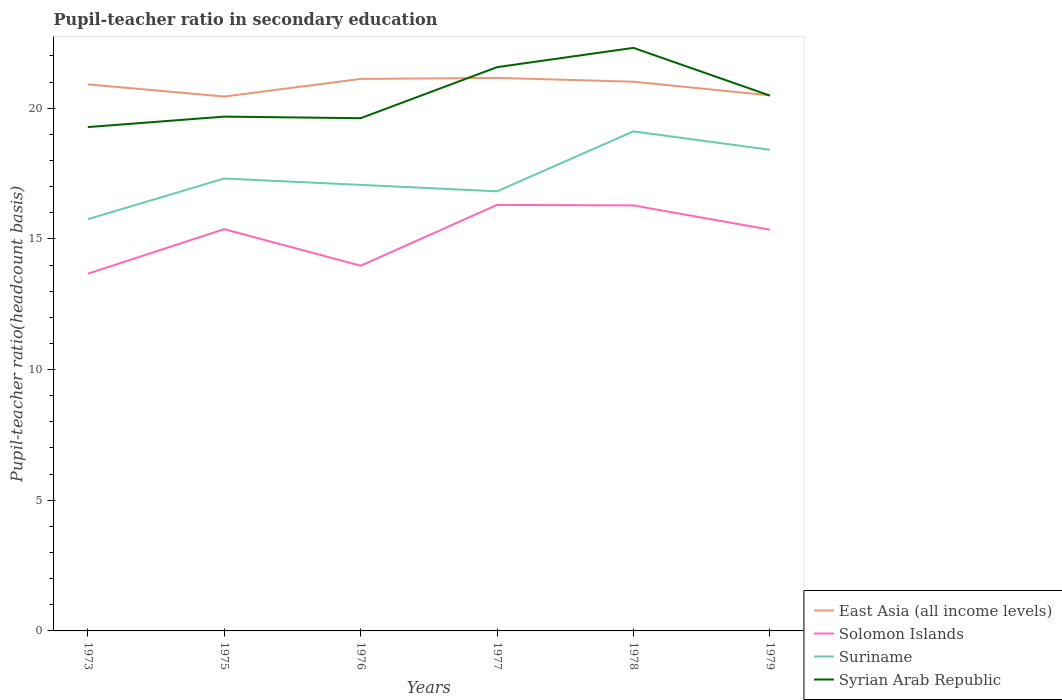Across all years, what is the maximum pupil-teacher ratio in secondary education in Syrian Arab Republic?
Your answer should be compact. 19.28. In which year was the pupil-teacher ratio in secondary education in East Asia (all income levels) maximum?
Keep it short and to the point. 1975. What is the total pupil-teacher ratio in secondary education in Syrian Arab Republic in the graph?
Your response must be concise. -0.34. What is the difference between the highest and the second highest pupil-teacher ratio in secondary education in Suriname?
Your response must be concise. 3.36. What is the difference between the highest and the lowest pupil-teacher ratio in secondary education in East Asia (all income levels)?
Offer a very short reply. 4. How many lines are there?
Your response must be concise. 4. What is the difference between two consecutive major ticks on the Y-axis?
Ensure brevity in your answer.  5. What is the title of the graph?
Give a very brief answer. Pupil-teacher ratio in secondary education. Does "East Asia (developing only)" appear as one of the legend labels in the graph?
Provide a succinct answer. No. What is the label or title of the X-axis?
Provide a short and direct response. Years. What is the label or title of the Y-axis?
Make the answer very short. Pupil-teacher ratio(headcount basis). What is the Pupil-teacher ratio(headcount basis) in East Asia (all income levels) in 1973?
Keep it short and to the point. 20.91. What is the Pupil-teacher ratio(headcount basis) of Solomon Islands in 1973?
Your answer should be compact. 13.67. What is the Pupil-teacher ratio(headcount basis) of Suriname in 1973?
Your answer should be very brief. 15.75. What is the Pupil-teacher ratio(headcount basis) of Syrian Arab Republic in 1973?
Offer a terse response. 19.28. What is the Pupil-teacher ratio(headcount basis) in East Asia (all income levels) in 1975?
Your response must be concise. 20.45. What is the Pupil-teacher ratio(headcount basis) in Solomon Islands in 1975?
Offer a terse response. 15.37. What is the Pupil-teacher ratio(headcount basis) in Suriname in 1975?
Provide a succinct answer. 17.31. What is the Pupil-teacher ratio(headcount basis) in Syrian Arab Republic in 1975?
Offer a terse response. 19.68. What is the Pupil-teacher ratio(headcount basis) in East Asia (all income levels) in 1976?
Provide a succinct answer. 21.12. What is the Pupil-teacher ratio(headcount basis) in Solomon Islands in 1976?
Provide a short and direct response. 13.97. What is the Pupil-teacher ratio(headcount basis) of Suriname in 1976?
Your answer should be very brief. 17.07. What is the Pupil-teacher ratio(headcount basis) of Syrian Arab Republic in 1976?
Give a very brief answer. 19.62. What is the Pupil-teacher ratio(headcount basis) in East Asia (all income levels) in 1977?
Offer a very short reply. 21.16. What is the Pupil-teacher ratio(headcount basis) of Solomon Islands in 1977?
Provide a succinct answer. 16.3. What is the Pupil-teacher ratio(headcount basis) in Suriname in 1977?
Ensure brevity in your answer.  16.82. What is the Pupil-teacher ratio(headcount basis) in Syrian Arab Republic in 1977?
Your answer should be very brief. 21.57. What is the Pupil-teacher ratio(headcount basis) in East Asia (all income levels) in 1978?
Make the answer very short. 21.02. What is the Pupil-teacher ratio(headcount basis) in Solomon Islands in 1978?
Your answer should be very brief. 16.28. What is the Pupil-teacher ratio(headcount basis) of Suriname in 1978?
Your answer should be compact. 19.12. What is the Pupil-teacher ratio(headcount basis) of Syrian Arab Republic in 1978?
Keep it short and to the point. 22.31. What is the Pupil-teacher ratio(headcount basis) of East Asia (all income levels) in 1979?
Your answer should be very brief. 20.49. What is the Pupil-teacher ratio(headcount basis) in Solomon Islands in 1979?
Keep it short and to the point. 15.35. What is the Pupil-teacher ratio(headcount basis) in Suriname in 1979?
Your answer should be compact. 18.41. What is the Pupil-teacher ratio(headcount basis) in Syrian Arab Republic in 1979?
Your response must be concise. 20.49. Across all years, what is the maximum Pupil-teacher ratio(headcount basis) of East Asia (all income levels)?
Your response must be concise. 21.16. Across all years, what is the maximum Pupil-teacher ratio(headcount basis) of Solomon Islands?
Make the answer very short. 16.3. Across all years, what is the maximum Pupil-teacher ratio(headcount basis) of Suriname?
Offer a terse response. 19.12. Across all years, what is the maximum Pupil-teacher ratio(headcount basis) in Syrian Arab Republic?
Your answer should be very brief. 22.31. Across all years, what is the minimum Pupil-teacher ratio(headcount basis) of East Asia (all income levels)?
Offer a very short reply. 20.45. Across all years, what is the minimum Pupil-teacher ratio(headcount basis) in Solomon Islands?
Offer a very short reply. 13.67. Across all years, what is the minimum Pupil-teacher ratio(headcount basis) in Suriname?
Keep it short and to the point. 15.75. Across all years, what is the minimum Pupil-teacher ratio(headcount basis) of Syrian Arab Republic?
Keep it short and to the point. 19.28. What is the total Pupil-teacher ratio(headcount basis) of East Asia (all income levels) in the graph?
Offer a terse response. 125.15. What is the total Pupil-teacher ratio(headcount basis) of Solomon Islands in the graph?
Offer a very short reply. 90.95. What is the total Pupil-teacher ratio(headcount basis) of Suriname in the graph?
Your response must be concise. 104.48. What is the total Pupil-teacher ratio(headcount basis) in Syrian Arab Republic in the graph?
Give a very brief answer. 122.95. What is the difference between the Pupil-teacher ratio(headcount basis) in East Asia (all income levels) in 1973 and that in 1975?
Give a very brief answer. 0.47. What is the difference between the Pupil-teacher ratio(headcount basis) in Solomon Islands in 1973 and that in 1975?
Your answer should be compact. -1.71. What is the difference between the Pupil-teacher ratio(headcount basis) in Suriname in 1973 and that in 1975?
Give a very brief answer. -1.56. What is the difference between the Pupil-teacher ratio(headcount basis) of Syrian Arab Republic in 1973 and that in 1975?
Provide a succinct answer. -0.4. What is the difference between the Pupil-teacher ratio(headcount basis) of East Asia (all income levels) in 1973 and that in 1976?
Your answer should be compact. -0.21. What is the difference between the Pupil-teacher ratio(headcount basis) of Solomon Islands in 1973 and that in 1976?
Offer a terse response. -0.31. What is the difference between the Pupil-teacher ratio(headcount basis) in Suriname in 1973 and that in 1976?
Provide a short and direct response. -1.31. What is the difference between the Pupil-teacher ratio(headcount basis) of Syrian Arab Republic in 1973 and that in 1976?
Give a very brief answer. -0.34. What is the difference between the Pupil-teacher ratio(headcount basis) in East Asia (all income levels) in 1973 and that in 1977?
Offer a very short reply. -0.25. What is the difference between the Pupil-teacher ratio(headcount basis) in Solomon Islands in 1973 and that in 1977?
Make the answer very short. -2.63. What is the difference between the Pupil-teacher ratio(headcount basis) of Suriname in 1973 and that in 1977?
Make the answer very short. -1.07. What is the difference between the Pupil-teacher ratio(headcount basis) of Syrian Arab Republic in 1973 and that in 1977?
Give a very brief answer. -2.29. What is the difference between the Pupil-teacher ratio(headcount basis) of East Asia (all income levels) in 1973 and that in 1978?
Ensure brevity in your answer.  -0.1. What is the difference between the Pupil-teacher ratio(headcount basis) of Solomon Islands in 1973 and that in 1978?
Offer a very short reply. -2.61. What is the difference between the Pupil-teacher ratio(headcount basis) in Suriname in 1973 and that in 1978?
Provide a succinct answer. -3.36. What is the difference between the Pupil-teacher ratio(headcount basis) in Syrian Arab Republic in 1973 and that in 1978?
Provide a short and direct response. -3.03. What is the difference between the Pupil-teacher ratio(headcount basis) of East Asia (all income levels) in 1973 and that in 1979?
Your answer should be very brief. 0.42. What is the difference between the Pupil-teacher ratio(headcount basis) of Solomon Islands in 1973 and that in 1979?
Offer a terse response. -1.68. What is the difference between the Pupil-teacher ratio(headcount basis) in Suriname in 1973 and that in 1979?
Your answer should be compact. -2.66. What is the difference between the Pupil-teacher ratio(headcount basis) in Syrian Arab Republic in 1973 and that in 1979?
Provide a short and direct response. -1.21. What is the difference between the Pupil-teacher ratio(headcount basis) in East Asia (all income levels) in 1975 and that in 1976?
Provide a short and direct response. -0.67. What is the difference between the Pupil-teacher ratio(headcount basis) in Solomon Islands in 1975 and that in 1976?
Offer a very short reply. 1.4. What is the difference between the Pupil-teacher ratio(headcount basis) of Suriname in 1975 and that in 1976?
Offer a very short reply. 0.24. What is the difference between the Pupil-teacher ratio(headcount basis) in Syrian Arab Republic in 1975 and that in 1976?
Provide a short and direct response. 0.06. What is the difference between the Pupil-teacher ratio(headcount basis) in East Asia (all income levels) in 1975 and that in 1977?
Give a very brief answer. -0.71. What is the difference between the Pupil-teacher ratio(headcount basis) in Solomon Islands in 1975 and that in 1977?
Your answer should be compact. -0.93. What is the difference between the Pupil-teacher ratio(headcount basis) of Suriname in 1975 and that in 1977?
Your answer should be very brief. 0.49. What is the difference between the Pupil-teacher ratio(headcount basis) of Syrian Arab Republic in 1975 and that in 1977?
Offer a very short reply. -1.89. What is the difference between the Pupil-teacher ratio(headcount basis) in East Asia (all income levels) in 1975 and that in 1978?
Offer a terse response. -0.57. What is the difference between the Pupil-teacher ratio(headcount basis) in Solomon Islands in 1975 and that in 1978?
Offer a very short reply. -0.91. What is the difference between the Pupil-teacher ratio(headcount basis) of Suriname in 1975 and that in 1978?
Provide a short and direct response. -1.8. What is the difference between the Pupil-teacher ratio(headcount basis) of Syrian Arab Republic in 1975 and that in 1978?
Your response must be concise. -2.63. What is the difference between the Pupil-teacher ratio(headcount basis) in East Asia (all income levels) in 1975 and that in 1979?
Keep it short and to the point. -0.04. What is the difference between the Pupil-teacher ratio(headcount basis) of Solomon Islands in 1975 and that in 1979?
Give a very brief answer. 0.02. What is the difference between the Pupil-teacher ratio(headcount basis) in Suriname in 1975 and that in 1979?
Ensure brevity in your answer.  -1.1. What is the difference between the Pupil-teacher ratio(headcount basis) of Syrian Arab Republic in 1975 and that in 1979?
Your response must be concise. -0.81. What is the difference between the Pupil-teacher ratio(headcount basis) of East Asia (all income levels) in 1976 and that in 1977?
Your response must be concise. -0.04. What is the difference between the Pupil-teacher ratio(headcount basis) in Solomon Islands in 1976 and that in 1977?
Keep it short and to the point. -2.33. What is the difference between the Pupil-teacher ratio(headcount basis) of Suriname in 1976 and that in 1977?
Ensure brevity in your answer.  0.25. What is the difference between the Pupil-teacher ratio(headcount basis) in Syrian Arab Republic in 1976 and that in 1977?
Your answer should be compact. -1.95. What is the difference between the Pupil-teacher ratio(headcount basis) of East Asia (all income levels) in 1976 and that in 1978?
Keep it short and to the point. 0.11. What is the difference between the Pupil-teacher ratio(headcount basis) of Solomon Islands in 1976 and that in 1978?
Provide a short and direct response. -2.31. What is the difference between the Pupil-teacher ratio(headcount basis) of Suriname in 1976 and that in 1978?
Ensure brevity in your answer.  -2.05. What is the difference between the Pupil-teacher ratio(headcount basis) of Syrian Arab Republic in 1976 and that in 1978?
Give a very brief answer. -2.69. What is the difference between the Pupil-teacher ratio(headcount basis) in East Asia (all income levels) in 1976 and that in 1979?
Your response must be concise. 0.63. What is the difference between the Pupil-teacher ratio(headcount basis) of Solomon Islands in 1976 and that in 1979?
Keep it short and to the point. -1.38. What is the difference between the Pupil-teacher ratio(headcount basis) in Suriname in 1976 and that in 1979?
Keep it short and to the point. -1.34. What is the difference between the Pupil-teacher ratio(headcount basis) of Syrian Arab Republic in 1976 and that in 1979?
Ensure brevity in your answer.  -0.87. What is the difference between the Pupil-teacher ratio(headcount basis) in East Asia (all income levels) in 1977 and that in 1978?
Offer a terse response. 0.15. What is the difference between the Pupil-teacher ratio(headcount basis) in Solomon Islands in 1977 and that in 1978?
Your response must be concise. 0.02. What is the difference between the Pupil-teacher ratio(headcount basis) of Suriname in 1977 and that in 1978?
Provide a short and direct response. -2.29. What is the difference between the Pupil-teacher ratio(headcount basis) of Syrian Arab Republic in 1977 and that in 1978?
Offer a very short reply. -0.74. What is the difference between the Pupil-teacher ratio(headcount basis) of East Asia (all income levels) in 1977 and that in 1979?
Your answer should be very brief. 0.67. What is the difference between the Pupil-teacher ratio(headcount basis) in Solomon Islands in 1977 and that in 1979?
Give a very brief answer. 0.95. What is the difference between the Pupil-teacher ratio(headcount basis) of Suriname in 1977 and that in 1979?
Keep it short and to the point. -1.59. What is the difference between the Pupil-teacher ratio(headcount basis) of Syrian Arab Republic in 1977 and that in 1979?
Make the answer very short. 1.09. What is the difference between the Pupil-teacher ratio(headcount basis) of East Asia (all income levels) in 1978 and that in 1979?
Keep it short and to the point. 0.52. What is the difference between the Pupil-teacher ratio(headcount basis) of Solomon Islands in 1978 and that in 1979?
Make the answer very short. 0.93. What is the difference between the Pupil-teacher ratio(headcount basis) in Suriname in 1978 and that in 1979?
Your answer should be compact. 0.71. What is the difference between the Pupil-teacher ratio(headcount basis) in Syrian Arab Republic in 1978 and that in 1979?
Ensure brevity in your answer.  1.82. What is the difference between the Pupil-teacher ratio(headcount basis) of East Asia (all income levels) in 1973 and the Pupil-teacher ratio(headcount basis) of Solomon Islands in 1975?
Give a very brief answer. 5.54. What is the difference between the Pupil-teacher ratio(headcount basis) in East Asia (all income levels) in 1973 and the Pupil-teacher ratio(headcount basis) in Suriname in 1975?
Offer a very short reply. 3.6. What is the difference between the Pupil-teacher ratio(headcount basis) of East Asia (all income levels) in 1973 and the Pupil-teacher ratio(headcount basis) of Syrian Arab Republic in 1975?
Your answer should be very brief. 1.23. What is the difference between the Pupil-teacher ratio(headcount basis) of Solomon Islands in 1973 and the Pupil-teacher ratio(headcount basis) of Suriname in 1975?
Your answer should be very brief. -3.64. What is the difference between the Pupil-teacher ratio(headcount basis) in Solomon Islands in 1973 and the Pupil-teacher ratio(headcount basis) in Syrian Arab Republic in 1975?
Offer a terse response. -6.01. What is the difference between the Pupil-teacher ratio(headcount basis) of Suriname in 1973 and the Pupil-teacher ratio(headcount basis) of Syrian Arab Republic in 1975?
Offer a terse response. -3.93. What is the difference between the Pupil-teacher ratio(headcount basis) in East Asia (all income levels) in 1973 and the Pupil-teacher ratio(headcount basis) in Solomon Islands in 1976?
Offer a terse response. 6.94. What is the difference between the Pupil-teacher ratio(headcount basis) of East Asia (all income levels) in 1973 and the Pupil-teacher ratio(headcount basis) of Suriname in 1976?
Provide a short and direct response. 3.85. What is the difference between the Pupil-teacher ratio(headcount basis) in East Asia (all income levels) in 1973 and the Pupil-teacher ratio(headcount basis) in Syrian Arab Republic in 1976?
Offer a very short reply. 1.3. What is the difference between the Pupil-teacher ratio(headcount basis) of Solomon Islands in 1973 and the Pupil-teacher ratio(headcount basis) of Suriname in 1976?
Give a very brief answer. -3.4. What is the difference between the Pupil-teacher ratio(headcount basis) of Solomon Islands in 1973 and the Pupil-teacher ratio(headcount basis) of Syrian Arab Republic in 1976?
Your answer should be compact. -5.95. What is the difference between the Pupil-teacher ratio(headcount basis) of Suriname in 1973 and the Pupil-teacher ratio(headcount basis) of Syrian Arab Republic in 1976?
Ensure brevity in your answer.  -3.86. What is the difference between the Pupil-teacher ratio(headcount basis) of East Asia (all income levels) in 1973 and the Pupil-teacher ratio(headcount basis) of Solomon Islands in 1977?
Ensure brevity in your answer.  4.61. What is the difference between the Pupil-teacher ratio(headcount basis) in East Asia (all income levels) in 1973 and the Pupil-teacher ratio(headcount basis) in Suriname in 1977?
Your response must be concise. 4.09. What is the difference between the Pupil-teacher ratio(headcount basis) of East Asia (all income levels) in 1973 and the Pupil-teacher ratio(headcount basis) of Syrian Arab Republic in 1977?
Provide a succinct answer. -0.66. What is the difference between the Pupil-teacher ratio(headcount basis) of Solomon Islands in 1973 and the Pupil-teacher ratio(headcount basis) of Suriname in 1977?
Your answer should be very brief. -3.15. What is the difference between the Pupil-teacher ratio(headcount basis) in Solomon Islands in 1973 and the Pupil-teacher ratio(headcount basis) in Syrian Arab Republic in 1977?
Your response must be concise. -7.9. What is the difference between the Pupil-teacher ratio(headcount basis) in Suriname in 1973 and the Pupil-teacher ratio(headcount basis) in Syrian Arab Republic in 1977?
Keep it short and to the point. -5.82. What is the difference between the Pupil-teacher ratio(headcount basis) in East Asia (all income levels) in 1973 and the Pupil-teacher ratio(headcount basis) in Solomon Islands in 1978?
Your response must be concise. 4.63. What is the difference between the Pupil-teacher ratio(headcount basis) of East Asia (all income levels) in 1973 and the Pupil-teacher ratio(headcount basis) of Suriname in 1978?
Ensure brevity in your answer.  1.8. What is the difference between the Pupil-teacher ratio(headcount basis) of East Asia (all income levels) in 1973 and the Pupil-teacher ratio(headcount basis) of Syrian Arab Republic in 1978?
Keep it short and to the point. -1.4. What is the difference between the Pupil-teacher ratio(headcount basis) of Solomon Islands in 1973 and the Pupil-teacher ratio(headcount basis) of Suriname in 1978?
Your answer should be compact. -5.45. What is the difference between the Pupil-teacher ratio(headcount basis) in Solomon Islands in 1973 and the Pupil-teacher ratio(headcount basis) in Syrian Arab Republic in 1978?
Offer a terse response. -8.64. What is the difference between the Pupil-teacher ratio(headcount basis) in Suriname in 1973 and the Pupil-teacher ratio(headcount basis) in Syrian Arab Republic in 1978?
Offer a terse response. -6.56. What is the difference between the Pupil-teacher ratio(headcount basis) in East Asia (all income levels) in 1973 and the Pupil-teacher ratio(headcount basis) in Solomon Islands in 1979?
Provide a short and direct response. 5.56. What is the difference between the Pupil-teacher ratio(headcount basis) in East Asia (all income levels) in 1973 and the Pupil-teacher ratio(headcount basis) in Suriname in 1979?
Your response must be concise. 2.5. What is the difference between the Pupil-teacher ratio(headcount basis) in East Asia (all income levels) in 1973 and the Pupil-teacher ratio(headcount basis) in Syrian Arab Republic in 1979?
Provide a short and direct response. 0.43. What is the difference between the Pupil-teacher ratio(headcount basis) of Solomon Islands in 1973 and the Pupil-teacher ratio(headcount basis) of Suriname in 1979?
Your response must be concise. -4.74. What is the difference between the Pupil-teacher ratio(headcount basis) in Solomon Islands in 1973 and the Pupil-teacher ratio(headcount basis) in Syrian Arab Republic in 1979?
Offer a terse response. -6.82. What is the difference between the Pupil-teacher ratio(headcount basis) of Suriname in 1973 and the Pupil-teacher ratio(headcount basis) of Syrian Arab Republic in 1979?
Give a very brief answer. -4.73. What is the difference between the Pupil-teacher ratio(headcount basis) in East Asia (all income levels) in 1975 and the Pupil-teacher ratio(headcount basis) in Solomon Islands in 1976?
Keep it short and to the point. 6.47. What is the difference between the Pupil-teacher ratio(headcount basis) in East Asia (all income levels) in 1975 and the Pupil-teacher ratio(headcount basis) in Suriname in 1976?
Give a very brief answer. 3.38. What is the difference between the Pupil-teacher ratio(headcount basis) of East Asia (all income levels) in 1975 and the Pupil-teacher ratio(headcount basis) of Syrian Arab Republic in 1976?
Your response must be concise. 0.83. What is the difference between the Pupil-teacher ratio(headcount basis) in Solomon Islands in 1975 and the Pupil-teacher ratio(headcount basis) in Suriname in 1976?
Provide a succinct answer. -1.69. What is the difference between the Pupil-teacher ratio(headcount basis) of Solomon Islands in 1975 and the Pupil-teacher ratio(headcount basis) of Syrian Arab Republic in 1976?
Your answer should be very brief. -4.24. What is the difference between the Pupil-teacher ratio(headcount basis) in Suriname in 1975 and the Pupil-teacher ratio(headcount basis) in Syrian Arab Republic in 1976?
Offer a very short reply. -2.31. What is the difference between the Pupil-teacher ratio(headcount basis) in East Asia (all income levels) in 1975 and the Pupil-teacher ratio(headcount basis) in Solomon Islands in 1977?
Provide a short and direct response. 4.15. What is the difference between the Pupil-teacher ratio(headcount basis) of East Asia (all income levels) in 1975 and the Pupil-teacher ratio(headcount basis) of Suriname in 1977?
Provide a succinct answer. 3.63. What is the difference between the Pupil-teacher ratio(headcount basis) of East Asia (all income levels) in 1975 and the Pupil-teacher ratio(headcount basis) of Syrian Arab Republic in 1977?
Your answer should be compact. -1.12. What is the difference between the Pupil-teacher ratio(headcount basis) in Solomon Islands in 1975 and the Pupil-teacher ratio(headcount basis) in Suriname in 1977?
Give a very brief answer. -1.45. What is the difference between the Pupil-teacher ratio(headcount basis) of Solomon Islands in 1975 and the Pupil-teacher ratio(headcount basis) of Syrian Arab Republic in 1977?
Provide a succinct answer. -6.2. What is the difference between the Pupil-teacher ratio(headcount basis) in Suriname in 1975 and the Pupil-teacher ratio(headcount basis) in Syrian Arab Republic in 1977?
Offer a terse response. -4.26. What is the difference between the Pupil-teacher ratio(headcount basis) in East Asia (all income levels) in 1975 and the Pupil-teacher ratio(headcount basis) in Solomon Islands in 1978?
Give a very brief answer. 4.17. What is the difference between the Pupil-teacher ratio(headcount basis) of East Asia (all income levels) in 1975 and the Pupil-teacher ratio(headcount basis) of Suriname in 1978?
Provide a short and direct response. 1.33. What is the difference between the Pupil-teacher ratio(headcount basis) in East Asia (all income levels) in 1975 and the Pupil-teacher ratio(headcount basis) in Syrian Arab Republic in 1978?
Offer a very short reply. -1.86. What is the difference between the Pupil-teacher ratio(headcount basis) of Solomon Islands in 1975 and the Pupil-teacher ratio(headcount basis) of Suriname in 1978?
Ensure brevity in your answer.  -3.74. What is the difference between the Pupil-teacher ratio(headcount basis) in Solomon Islands in 1975 and the Pupil-teacher ratio(headcount basis) in Syrian Arab Republic in 1978?
Ensure brevity in your answer.  -6.94. What is the difference between the Pupil-teacher ratio(headcount basis) of Suriname in 1975 and the Pupil-teacher ratio(headcount basis) of Syrian Arab Republic in 1978?
Provide a short and direct response. -5. What is the difference between the Pupil-teacher ratio(headcount basis) of East Asia (all income levels) in 1975 and the Pupil-teacher ratio(headcount basis) of Solomon Islands in 1979?
Provide a short and direct response. 5.1. What is the difference between the Pupil-teacher ratio(headcount basis) of East Asia (all income levels) in 1975 and the Pupil-teacher ratio(headcount basis) of Suriname in 1979?
Ensure brevity in your answer.  2.04. What is the difference between the Pupil-teacher ratio(headcount basis) in East Asia (all income levels) in 1975 and the Pupil-teacher ratio(headcount basis) in Syrian Arab Republic in 1979?
Ensure brevity in your answer.  -0.04. What is the difference between the Pupil-teacher ratio(headcount basis) of Solomon Islands in 1975 and the Pupil-teacher ratio(headcount basis) of Suriname in 1979?
Offer a very short reply. -3.04. What is the difference between the Pupil-teacher ratio(headcount basis) of Solomon Islands in 1975 and the Pupil-teacher ratio(headcount basis) of Syrian Arab Republic in 1979?
Your answer should be very brief. -5.11. What is the difference between the Pupil-teacher ratio(headcount basis) in Suriname in 1975 and the Pupil-teacher ratio(headcount basis) in Syrian Arab Republic in 1979?
Your answer should be compact. -3.17. What is the difference between the Pupil-teacher ratio(headcount basis) of East Asia (all income levels) in 1976 and the Pupil-teacher ratio(headcount basis) of Solomon Islands in 1977?
Make the answer very short. 4.82. What is the difference between the Pupil-teacher ratio(headcount basis) in East Asia (all income levels) in 1976 and the Pupil-teacher ratio(headcount basis) in Suriname in 1977?
Give a very brief answer. 4.3. What is the difference between the Pupil-teacher ratio(headcount basis) in East Asia (all income levels) in 1976 and the Pupil-teacher ratio(headcount basis) in Syrian Arab Republic in 1977?
Offer a terse response. -0.45. What is the difference between the Pupil-teacher ratio(headcount basis) of Solomon Islands in 1976 and the Pupil-teacher ratio(headcount basis) of Suriname in 1977?
Give a very brief answer. -2.85. What is the difference between the Pupil-teacher ratio(headcount basis) in Solomon Islands in 1976 and the Pupil-teacher ratio(headcount basis) in Syrian Arab Republic in 1977?
Your answer should be compact. -7.6. What is the difference between the Pupil-teacher ratio(headcount basis) of Suriname in 1976 and the Pupil-teacher ratio(headcount basis) of Syrian Arab Republic in 1977?
Ensure brevity in your answer.  -4.5. What is the difference between the Pupil-teacher ratio(headcount basis) in East Asia (all income levels) in 1976 and the Pupil-teacher ratio(headcount basis) in Solomon Islands in 1978?
Offer a terse response. 4.84. What is the difference between the Pupil-teacher ratio(headcount basis) of East Asia (all income levels) in 1976 and the Pupil-teacher ratio(headcount basis) of Suriname in 1978?
Make the answer very short. 2.01. What is the difference between the Pupil-teacher ratio(headcount basis) of East Asia (all income levels) in 1976 and the Pupil-teacher ratio(headcount basis) of Syrian Arab Republic in 1978?
Your response must be concise. -1.19. What is the difference between the Pupil-teacher ratio(headcount basis) of Solomon Islands in 1976 and the Pupil-teacher ratio(headcount basis) of Suriname in 1978?
Make the answer very short. -5.14. What is the difference between the Pupil-teacher ratio(headcount basis) in Solomon Islands in 1976 and the Pupil-teacher ratio(headcount basis) in Syrian Arab Republic in 1978?
Keep it short and to the point. -8.34. What is the difference between the Pupil-teacher ratio(headcount basis) of Suriname in 1976 and the Pupil-teacher ratio(headcount basis) of Syrian Arab Republic in 1978?
Ensure brevity in your answer.  -5.24. What is the difference between the Pupil-teacher ratio(headcount basis) in East Asia (all income levels) in 1976 and the Pupil-teacher ratio(headcount basis) in Solomon Islands in 1979?
Provide a succinct answer. 5.77. What is the difference between the Pupil-teacher ratio(headcount basis) in East Asia (all income levels) in 1976 and the Pupil-teacher ratio(headcount basis) in Suriname in 1979?
Offer a very short reply. 2.71. What is the difference between the Pupil-teacher ratio(headcount basis) in East Asia (all income levels) in 1976 and the Pupil-teacher ratio(headcount basis) in Syrian Arab Republic in 1979?
Ensure brevity in your answer.  0.64. What is the difference between the Pupil-teacher ratio(headcount basis) in Solomon Islands in 1976 and the Pupil-teacher ratio(headcount basis) in Suriname in 1979?
Your response must be concise. -4.44. What is the difference between the Pupil-teacher ratio(headcount basis) of Solomon Islands in 1976 and the Pupil-teacher ratio(headcount basis) of Syrian Arab Republic in 1979?
Provide a succinct answer. -6.51. What is the difference between the Pupil-teacher ratio(headcount basis) in Suriname in 1976 and the Pupil-teacher ratio(headcount basis) in Syrian Arab Republic in 1979?
Keep it short and to the point. -3.42. What is the difference between the Pupil-teacher ratio(headcount basis) of East Asia (all income levels) in 1977 and the Pupil-teacher ratio(headcount basis) of Solomon Islands in 1978?
Keep it short and to the point. 4.88. What is the difference between the Pupil-teacher ratio(headcount basis) in East Asia (all income levels) in 1977 and the Pupil-teacher ratio(headcount basis) in Suriname in 1978?
Give a very brief answer. 2.05. What is the difference between the Pupil-teacher ratio(headcount basis) in East Asia (all income levels) in 1977 and the Pupil-teacher ratio(headcount basis) in Syrian Arab Republic in 1978?
Your answer should be compact. -1.15. What is the difference between the Pupil-teacher ratio(headcount basis) in Solomon Islands in 1977 and the Pupil-teacher ratio(headcount basis) in Suriname in 1978?
Offer a very short reply. -2.81. What is the difference between the Pupil-teacher ratio(headcount basis) of Solomon Islands in 1977 and the Pupil-teacher ratio(headcount basis) of Syrian Arab Republic in 1978?
Give a very brief answer. -6.01. What is the difference between the Pupil-teacher ratio(headcount basis) in Suriname in 1977 and the Pupil-teacher ratio(headcount basis) in Syrian Arab Republic in 1978?
Ensure brevity in your answer.  -5.49. What is the difference between the Pupil-teacher ratio(headcount basis) of East Asia (all income levels) in 1977 and the Pupil-teacher ratio(headcount basis) of Solomon Islands in 1979?
Make the answer very short. 5.81. What is the difference between the Pupil-teacher ratio(headcount basis) in East Asia (all income levels) in 1977 and the Pupil-teacher ratio(headcount basis) in Suriname in 1979?
Keep it short and to the point. 2.75. What is the difference between the Pupil-teacher ratio(headcount basis) in East Asia (all income levels) in 1977 and the Pupil-teacher ratio(headcount basis) in Syrian Arab Republic in 1979?
Ensure brevity in your answer.  0.68. What is the difference between the Pupil-teacher ratio(headcount basis) of Solomon Islands in 1977 and the Pupil-teacher ratio(headcount basis) of Suriname in 1979?
Ensure brevity in your answer.  -2.11. What is the difference between the Pupil-teacher ratio(headcount basis) in Solomon Islands in 1977 and the Pupil-teacher ratio(headcount basis) in Syrian Arab Republic in 1979?
Ensure brevity in your answer.  -4.18. What is the difference between the Pupil-teacher ratio(headcount basis) of Suriname in 1977 and the Pupil-teacher ratio(headcount basis) of Syrian Arab Republic in 1979?
Offer a terse response. -3.66. What is the difference between the Pupil-teacher ratio(headcount basis) in East Asia (all income levels) in 1978 and the Pupil-teacher ratio(headcount basis) in Solomon Islands in 1979?
Your response must be concise. 5.66. What is the difference between the Pupil-teacher ratio(headcount basis) in East Asia (all income levels) in 1978 and the Pupil-teacher ratio(headcount basis) in Suriname in 1979?
Offer a terse response. 2.61. What is the difference between the Pupil-teacher ratio(headcount basis) in East Asia (all income levels) in 1978 and the Pupil-teacher ratio(headcount basis) in Syrian Arab Republic in 1979?
Keep it short and to the point. 0.53. What is the difference between the Pupil-teacher ratio(headcount basis) of Solomon Islands in 1978 and the Pupil-teacher ratio(headcount basis) of Suriname in 1979?
Ensure brevity in your answer.  -2.13. What is the difference between the Pupil-teacher ratio(headcount basis) of Solomon Islands in 1978 and the Pupil-teacher ratio(headcount basis) of Syrian Arab Republic in 1979?
Ensure brevity in your answer.  -4.2. What is the difference between the Pupil-teacher ratio(headcount basis) in Suriname in 1978 and the Pupil-teacher ratio(headcount basis) in Syrian Arab Republic in 1979?
Your response must be concise. -1.37. What is the average Pupil-teacher ratio(headcount basis) of East Asia (all income levels) per year?
Give a very brief answer. 20.86. What is the average Pupil-teacher ratio(headcount basis) of Solomon Islands per year?
Your answer should be compact. 15.16. What is the average Pupil-teacher ratio(headcount basis) in Suriname per year?
Give a very brief answer. 17.41. What is the average Pupil-teacher ratio(headcount basis) in Syrian Arab Republic per year?
Keep it short and to the point. 20.49. In the year 1973, what is the difference between the Pupil-teacher ratio(headcount basis) in East Asia (all income levels) and Pupil-teacher ratio(headcount basis) in Solomon Islands?
Offer a very short reply. 7.25. In the year 1973, what is the difference between the Pupil-teacher ratio(headcount basis) in East Asia (all income levels) and Pupil-teacher ratio(headcount basis) in Suriname?
Your answer should be compact. 5.16. In the year 1973, what is the difference between the Pupil-teacher ratio(headcount basis) in East Asia (all income levels) and Pupil-teacher ratio(headcount basis) in Syrian Arab Republic?
Ensure brevity in your answer.  1.63. In the year 1973, what is the difference between the Pupil-teacher ratio(headcount basis) in Solomon Islands and Pupil-teacher ratio(headcount basis) in Suriname?
Make the answer very short. -2.09. In the year 1973, what is the difference between the Pupil-teacher ratio(headcount basis) in Solomon Islands and Pupil-teacher ratio(headcount basis) in Syrian Arab Republic?
Provide a succinct answer. -5.61. In the year 1973, what is the difference between the Pupil-teacher ratio(headcount basis) in Suriname and Pupil-teacher ratio(headcount basis) in Syrian Arab Republic?
Your answer should be compact. -3.52. In the year 1975, what is the difference between the Pupil-teacher ratio(headcount basis) of East Asia (all income levels) and Pupil-teacher ratio(headcount basis) of Solomon Islands?
Make the answer very short. 5.07. In the year 1975, what is the difference between the Pupil-teacher ratio(headcount basis) of East Asia (all income levels) and Pupil-teacher ratio(headcount basis) of Suriname?
Your answer should be very brief. 3.14. In the year 1975, what is the difference between the Pupil-teacher ratio(headcount basis) in East Asia (all income levels) and Pupil-teacher ratio(headcount basis) in Syrian Arab Republic?
Give a very brief answer. 0.77. In the year 1975, what is the difference between the Pupil-teacher ratio(headcount basis) in Solomon Islands and Pupil-teacher ratio(headcount basis) in Suriname?
Your answer should be compact. -1.94. In the year 1975, what is the difference between the Pupil-teacher ratio(headcount basis) of Solomon Islands and Pupil-teacher ratio(headcount basis) of Syrian Arab Republic?
Provide a succinct answer. -4.31. In the year 1975, what is the difference between the Pupil-teacher ratio(headcount basis) of Suriname and Pupil-teacher ratio(headcount basis) of Syrian Arab Republic?
Ensure brevity in your answer.  -2.37. In the year 1976, what is the difference between the Pupil-teacher ratio(headcount basis) of East Asia (all income levels) and Pupil-teacher ratio(headcount basis) of Solomon Islands?
Offer a very short reply. 7.15. In the year 1976, what is the difference between the Pupil-teacher ratio(headcount basis) in East Asia (all income levels) and Pupil-teacher ratio(headcount basis) in Suriname?
Ensure brevity in your answer.  4.05. In the year 1976, what is the difference between the Pupil-teacher ratio(headcount basis) in East Asia (all income levels) and Pupil-teacher ratio(headcount basis) in Syrian Arab Republic?
Provide a short and direct response. 1.5. In the year 1976, what is the difference between the Pupil-teacher ratio(headcount basis) in Solomon Islands and Pupil-teacher ratio(headcount basis) in Suriname?
Make the answer very short. -3.09. In the year 1976, what is the difference between the Pupil-teacher ratio(headcount basis) of Solomon Islands and Pupil-teacher ratio(headcount basis) of Syrian Arab Republic?
Give a very brief answer. -5.64. In the year 1976, what is the difference between the Pupil-teacher ratio(headcount basis) of Suriname and Pupil-teacher ratio(headcount basis) of Syrian Arab Republic?
Give a very brief answer. -2.55. In the year 1977, what is the difference between the Pupil-teacher ratio(headcount basis) in East Asia (all income levels) and Pupil-teacher ratio(headcount basis) in Solomon Islands?
Offer a very short reply. 4.86. In the year 1977, what is the difference between the Pupil-teacher ratio(headcount basis) in East Asia (all income levels) and Pupil-teacher ratio(headcount basis) in Suriname?
Make the answer very short. 4.34. In the year 1977, what is the difference between the Pupil-teacher ratio(headcount basis) in East Asia (all income levels) and Pupil-teacher ratio(headcount basis) in Syrian Arab Republic?
Provide a succinct answer. -0.41. In the year 1977, what is the difference between the Pupil-teacher ratio(headcount basis) of Solomon Islands and Pupil-teacher ratio(headcount basis) of Suriname?
Your answer should be very brief. -0.52. In the year 1977, what is the difference between the Pupil-teacher ratio(headcount basis) of Solomon Islands and Pupil-teacher ratio(headcount basis) of Syrian Arab Republic?
Keep it short and to the point. -5.27. In the year 1977, what is the difference between the Pupil-teacher ratio(headcount basis) in Suriname and Pupil-teacher ratio(headcount basis) in Syrian Arab Republic?
Your answer should be very brief. -4.75. In the year 1978, what is the difference between the Pupil-teacher ratio(headcount basis) of East Asia (all income levels) and Pupil-teacher ratio(headcount basis) of Solomon Islands?
Keep it short and to the point. 4.73. In the year 1978, what is the difference between the Pupil-teacher ratio(headcount basis) in East Asia (all income levels) and Pupil-teacher ratio(headcount basis) in Suriname?
Ensure brevity in your answer.  1.9. In the year 1978, what is the difference between the Pupil-teacher ratio(headcount basis) of East Asia (all income levels) and Pupil-teacher ratio(headcount basis) of Syrian Arab Republic?
Offer a very short reply. -1.29. In the year 1978, what is the difference between the Pupil-teacher ratio(headcount basis) of Solomon Islands and Pupil-teacher ratio(headcount basis) of Suriname?
Ensure brevity in your answer.  -2.83. In the year 1978, what is the difference between the Pupil-teacher ratio(headcount basis) of Solomon Islands and Pupil-teacher ratio(headcount basis) of Syrian Arab Republic?
Keep it short and to the point. -6.03. In the year 1978, what is the difference between the Pupil-teacher ratio(headcount basis) in Suriname and Pupil-teacher ratio(headcount basis) in Syrian Arab Republic?
Keep it short and to the point. -3.19. In the year 1979, what is the difference between the Pupil-teacher ratio(headcount basis) of East Asia (all income levels) and Pupil-teacher ratio(headcount basis) of Solomon Islands?
Offer a terse response. 5.14. In the year 1979, what is the difference between the Pupil-teacher ratio(headcount basis) of East Asia (all income levels) and Pupil-teacher ratio(headcount basis) of Suriname?
Offer a very short reply. 2.08. In the year 1979, what is the difference between the Pupil-teacher ratio(headcount basis) of East Asia (all income levels) and Pupil-teacher ratio(headcount basis) of Syrian Arab Republic?
Give a very brief answer. 0.01. In the year 1979, what is the difference between the Pupil-teacher ratio(headcount basis) in Solomon Islands and Pupil-teacher ratio(headcount basis) in Suriname?
Make the answer very short. -3.06. In the year 1979, what is the difference between the Pupil-teacher ratio(headcount basis) of Solomon Islands and Pupil-teacher ratio(headcount basis) of Syrian Arab Republic?
Keep it short and to the point. -5.13. In the year 1979, what is the difference between the Pupil-teacher ratio(headcount basis) of Suriname and Pupil-teacher ratio(headcount basis) of Syrian Arab Republic?
Offer a very short reply. -2.08. What is the ratio of the Pupil-teacher ratio(headcount basis) in East Asia (all income levels) in 1973 to that in 1975?
Provide a succinct answer. 1.02. What is the ratio of the Pupil-teacher ratio(headcount basis) in Solomon Islands in 1973 to that in 1975?
Make the answer very short. 0.89. What is the ratio of the Pupil-teacher ratio(headcount basis) in Suriname in 1973 to that in 1975?
Your response must be concise. 0.91. What is the ratio of the Pupil-teacher ratio(headcount basis) in Syrian Arab Republic in 1973 to that in 1975?
Give a very brief answer. 0.98. What is the ratio of the Pupil-teacher ratio(headcount basis) in East Asia (all income levels) in 1973 to that in 1976?
Provide a short and direct response. 0.99. What is the ratio of the Pupil-teacher ratio(headcount basis) in Solomon Islands in 1973 to that in 1976?
Offer a terse response. 0.98. What is the ratio of the Pupil-teacher ratio(headcount basis) in Suriname in 1973 to that in 1976?
Provide a succinct answer. 0.92. What is the ratio of the Pupil-teacher ratio(headcount basis) of Syrian Arab Republic in 1973 to that in 1976?
Give a very brief answer. 0.98. What is the ratio of the Pupil-teacher ratio(headcount basis) of East Asia (all income levels) in 1973 to that in 1977?
Your answer should be very brief. 0.99. What is the ratio of the Pupil-teacher ratio(headcount basis) in Solomon Islands in 1973 to that in 1977?
Your answer should be compact. 0.84. What is the ratio of the Pupil-teacher ratio(headcount basis) of Suriname in 1973 to that in 1977?
Your response must be concise. 0.94. What is the ratio of the Pupil-teacher ratio(headcount basis) of Syrian Arab Republic in 1973 to that in 1977?
Offer a terse response. 0.89. What is the ratio of the Pupil-teacher ratio(headcount basis) of Solomon Islands in 1973 to that in 1978?
Provide a short and direct response. 0.84. What is the ratio of the Pupil-teacher ratio(headcount basis) in Suriname in 1973 to that in 1978?
Offer a terse response. 0.82. What is the ratio of the Pupil-teacher ratio(headcount basis) in Syrian Arab Republic in 1973 to that in 1978?
Offer a very short reply. 0.86. What is the ratio of the Pupil-teacher ratio(headcount basis) of East Asia (all income levels) in 1973 to that in 1979?
Offer a very short reply. 1.02. What is the ratio of the Pupil-teacher ratio(headcount basis) in Solomon Islands in 1973 to that in 1979?
Your answer should be compact. 0.89. What is the ratio of the Pupil-teacher ratio(headcount basis) of Suriname in 1973 to that in 1979?
Provide a succinct answer. 0.86. What is the ratio of the Pupil-teacher ratio(headcount basis) in Syrian Arab Republic in 1973 to that in 1979?
Provide a short and direct response. 0.94. What is the ratio of the Pupil-teacher ratio(headcount basis) of East Asia (all income levels) in 1975 to that in 1976?
Your answer should be compact. 0.97. What is the ratio of the Pupil-teacher ratio(headcount basis) in Solomon Islands in 1975 to that in 1976?
Make the answer very short. 1.1. What is the ratio of the Pupil-teacher ratio(headcount basis) in Suriname in 1975 to that in 1976?
Provide a succinct answer. 1.01. What is the ratio of the Pupil-teacher ratio(headcount basis) of Syrian Arab Republic in 1975 to that in 1976?
Offer a very short reply. 1. What is the ratio of the Pupil-teacher ratio(headcount basis) of East Asia (all income levels) in 1975 to that in 1977?
Offer a very short reply. 0.97. What is the ratio of the Pupil-teacher ratio(headcount basis) in Solomon Islands in 1975 to that in 1977?
Keep it short and to the point. 0.94. What is the ratio of the Pupil-teacher ratio(headcount basis) of Suriname in 1975 to that in 1977?
Make the answer very short. 1.03. What is the ratio of the Pupil-teacher ratio(headcount basis) in Syrian Arab Republic in 1975 to that in 1977?
Your answer should be compact. 0.91. What is the ratio of the Pupil-teacher ratio(headcount basis) in East Asia (all income levels) in 1975 to that in 1978?
Keep it short and to the point. 0.97. What is the ratio of the Pupil-teacher ratio(headcount basis) of Solomon Islands in 1975 to that in 1978?
Make the answer very short. 0.94. What is the ratio of the Pupil-teacher ratio(headcount basis) in Suriname in 1975 to that in 1978?
Keep it short and to the point. 0.91. What is the ratio of the Pupil-teacher ratio(headcount basis) of Syrian Arab Republic in 1975 to that in 1978?
Ensure brevity in your answer.  0.88. What is the ratio of the Pupil-teacher ratio(headcount basis) in Solomon Islands in 1975 to that in 1979?
Ensure brevity in your answer.  1. What is the ratio of the Pupil-teacher ratio(headcount basis) of Suriname in 1975 to that in 1979?
Offer a very short reply. 0.94. What is the ratio of the Pupil-teacher ratio(headcount basis) in Syrian Arab Republic in 1975 to that in 1979?
Your response must be concise. 0.96. What is the ratio of the Pupil-teacher ratio(headcount basis) of Solomon Islands in 1976 to that in 1977?
Your response must be concise. 0.86. What is the ratio of the Pupil-teacher ratio(headcount basis) of Suriname in 1976 to that in 1977?
Your answer should be compact. 1.01. What is the ratio of the Pupil-teacher ratio(headcount basis) of Syrian Arab Republic in 1976 to that in 1977?
Give a very brief answer. 0.91. What is the ratio of the Pupil-teacher ratio(headcount basis) in East Asia (all income levels) in 1976 to that in 1978?
Your answer should be compact. 1. What is the ratio of the Pupil-teacher ratio(headcount basis) in Solomon Islands in 1976 to that in 1978?
Keep it short and to the point. 0.86. What is the ratio of the Pupil-teacher ratio(headcount basis) of Suriname in 1976 to that in 1978?
Make the answer very short. 0.89. What is the ratio of the Pupil-teacher ratio(headcount basis) in Syrian Arab Republic in 1976 to that in 1978?
Your answer should be very brief. 0.88. What is the ratio of the Pupil-teacher ratio(headcount basis) of East Asia (all income levels) in 1976 to that in 1979?
Make the answer very short. 1.03. What is the ratio of the Pupil-teacher ratio(headcount basis) of Solomon Islands in 1976 to that in 1979?
Provide a short and direct response. 0.91. What is the ratio of the Pupil-teacher ratio(headcount basis) of Suriname in 1976 to that in 1979?
Provide a short and direct response. 0.93. What is the ratio of the Pupil-teacher ratio(headcount basis) of Syrian Arab Republic in 1976 to that in 1979?
Provide a succinct answer. 0.96. What is the ratio of the Pupil-teacher ratio(headcount basis) in Suriname in 1977 to that in 1978?
Offer a terse response. 0.88. What is the ratio of the Pupil-teacher ratio(headcount basis) in Syrian Arab Republic in 1977 to that in 1978?
Your answer should be very brief. 0.97. What is the ratio of the Pupil-teacher ratio(headcount basis) in East Asia (all income levels) in 1977 to that in 1979?
Your answer should be compact. 1.03. What is the ratio of the Pupil-teacher ratio(headcount basis) of Solomon Islands in 1977 to that in 1979?
Provide a short and direct response. 1.06. What is the ratio of the Pupil-teacher ratio(headcount basis) of Suriname in 1977 to that in 1979?
Provide a succinct answer. 0.91. What is the ratio of the Pupil-teacher ratio(headcount basis) of Syrian Arab Republic in 1977 to that in 1979?
Provide a short and direct response. 1.05. What is the ratio of the Pupil-teacher ratio(headcount basis) in East Asia (all income levels) in 1978 to that in 1979?
Offer a very short reply. 1.03. What is the ratio of the Pupil-teacher ratio(headcount basis) in Solomon Islands in 1978 to that in 1979?
Provide a succinct answer. 1.06. What is the ratio of the Pupil-teacher ratio(headcount basis) of Suriname in 1978 to that in 1979?
Offer a very short reply. 1.04. What is the ratio of the Pupil-teacher ratio(headcount basis) of Syrian Arab Republic in 1978 to that in 1979?
Make the answer very short. 1.09. What is the difference between the highest and the second highest Pupil-teacher ratio(headcount basis) of East Asia (all income levels)?
Your answer should be compact. 0.04. What is the difference between the highest and the second highest Pupil-teacher ratio(headcount basis) in Solomon Islands?
Your response must be concise. 0.02. What is the difference between the highest and the second highest Pupil-teacher ratio(headcount basis) of Suriname?
Keep it short and to the point. 0.71. What is the difference between the highest and the second highest Pupil-teacher ratio(headcount basis) of Syrian Arab Republic?
Offer a very short reply. 0.74. What is the difference between the highest and the lowest Pupil-teacher ratio(headcount basis) in East Asia (all income levels)?
Ensure brevity in your answer.  0.71. What is the difference between the highest and the lowest Pupil-teacher ratio(headcount basis) in Solomon Islands?
Give a very brief answer. 2.63. What is the difference between the highest and the lowest Pupil-teacher ratio(headcount basis) in Suriname?
Provide a short and direct response. 3.36. What is the difference between the highest and the lowest Pupil-teacher ratio(headcount basis) of Syrian Arab Republic?
Keep it short and to the point. 3.03. 